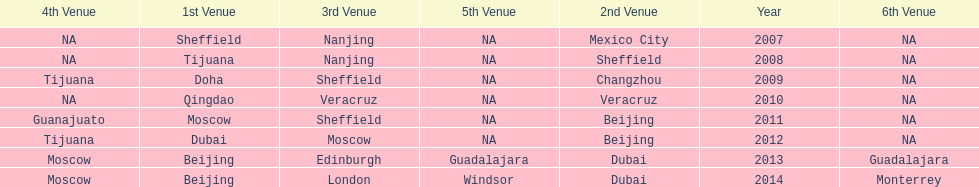In what year was the 3rd venue the same as 2011's 1st venue? 2012. 